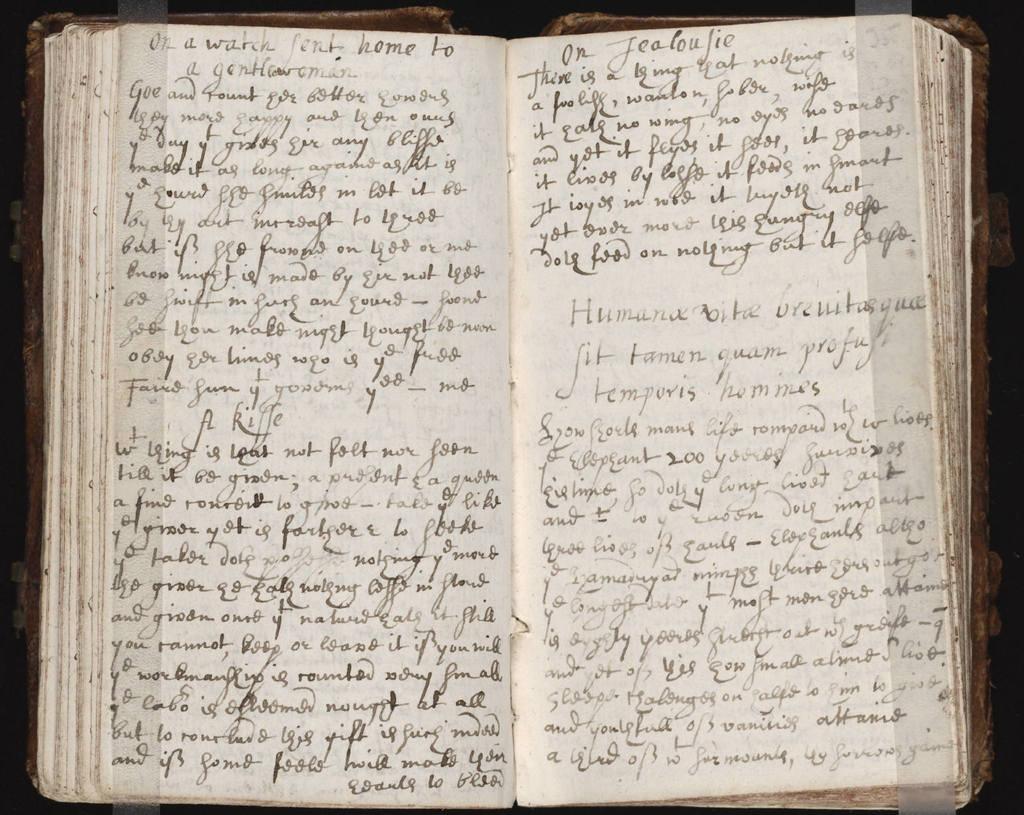What are the two words at the top of the right page?
Provide a succinct answer. On jealoujie. What is the first line on the top of left page?
Your answer should be very brief. On a watch sent home to. 